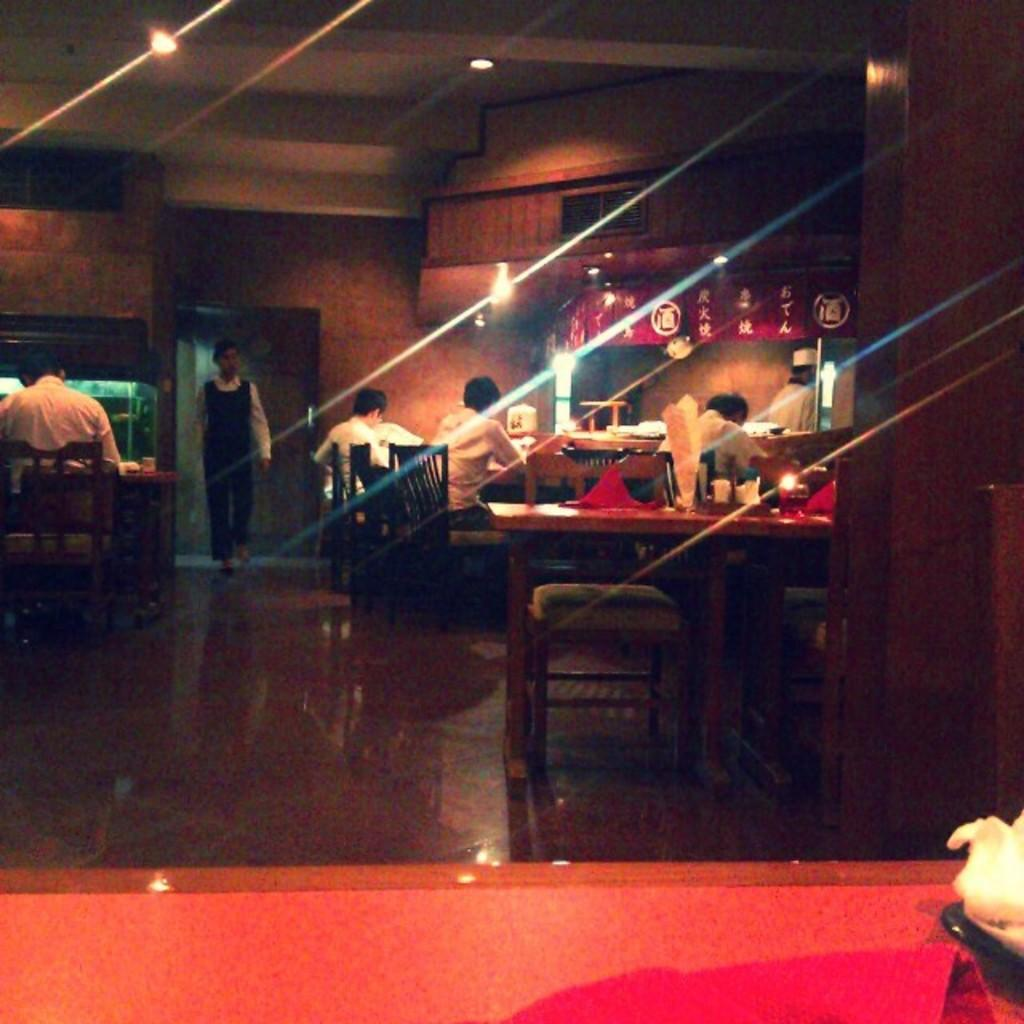How many people are in the image? There are persons in the image, but the exact number is not specified. What type of furniture is present in the image? There are chairs and tables in the image. What can be used for illumination in the image? There are lights in the image. What is visible in the background of the image? There is a wall in the background of the image. What is at the bottom of the image? There is a floor at the bottom of the image. What type of reward is being offered to the passenger in the image? There is no passenger or reward present in the image. What type of crime is being committed in the image? There is no crime being committed in the image. 